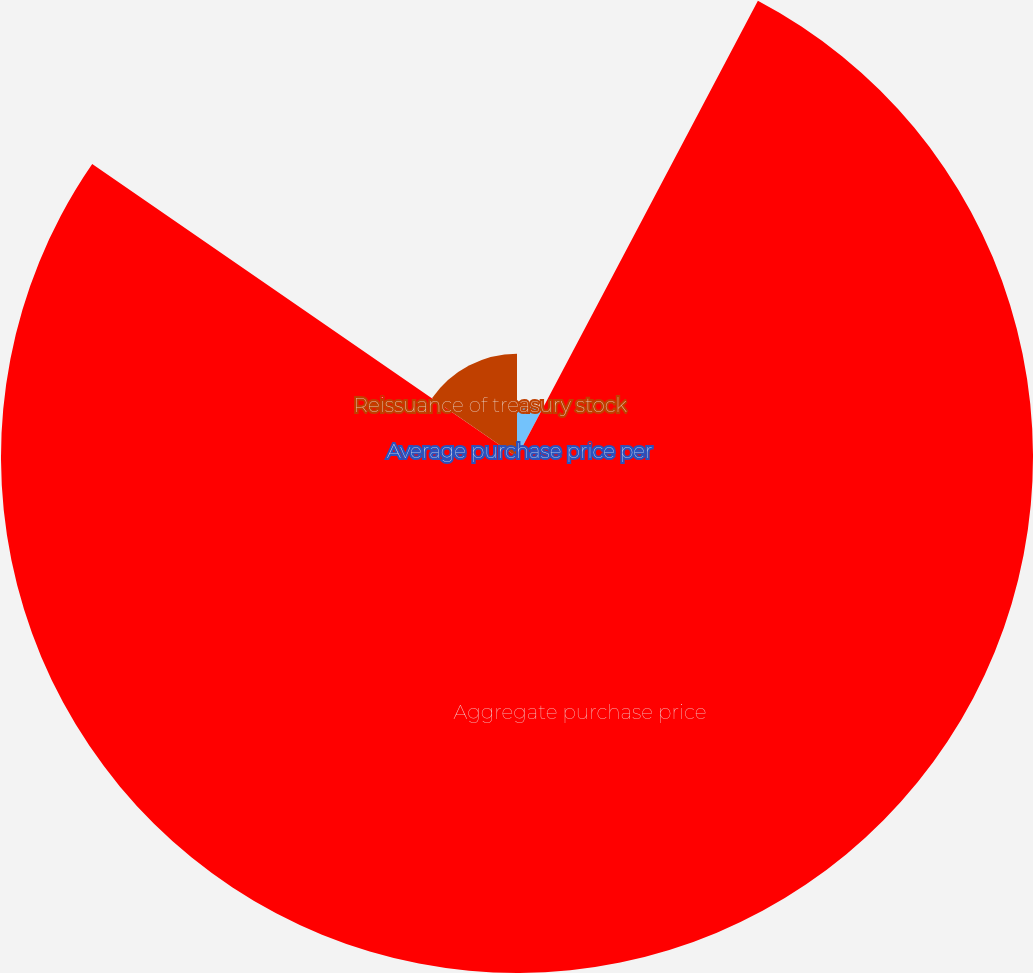Convert chart. <chart><loc_0><loc_0><loc_500><loc_500><pie_chart><fcel>Shares repurchased<fcel>Average purchase price per<fcel>Aggregate purchase price<fcel>Reissuance of treasury stock<nl><fcel>7.71%<fcel>0.02%<fcel>76.87%<fcel>15.39%<nl></chart> 